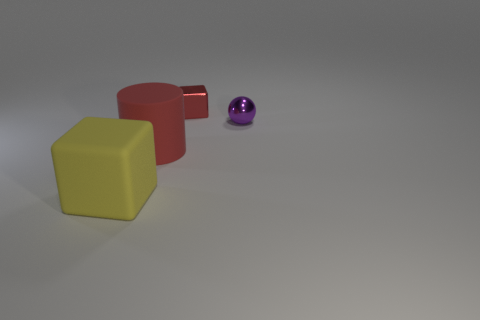Are there fewer yellow blocks than big yellow spheres?
Offer a terse response. No. There is a purple sphere; are there any tiny purple spheres on the right side of it?
Provide a succinct answer. No. There is a thing that is both on the right side of the big yellow matte object and on the left side of the red shiny cube; what shape is it?
Your answer should be compact. Cylinder. Are there any red rubber objects of the same shape as the purple object?
Provide a succinct answer. No. There is a matte thing left of the large red matte cylinder; does it have the same size as the red thing behind the big red matte thing?
Offer a very short reply. No. Are there more tiny spheres than tiny gray rubber balls?
Your answer should be compact. Yes. What number of other tiny red blocks are the same material as the small block?
Offer a very short reply. 0. Do the big yellow object and the red matte object have the same shape?
Your response must be concise. No. How big is the cylinder in front of the block to the right of the rubber thing right of the yellow object?
Give a very brief answer. Large. Are there any blocks that are on the left side of the thing that is behind the purple metal ball?
Your answer should be very brief. Yes. 